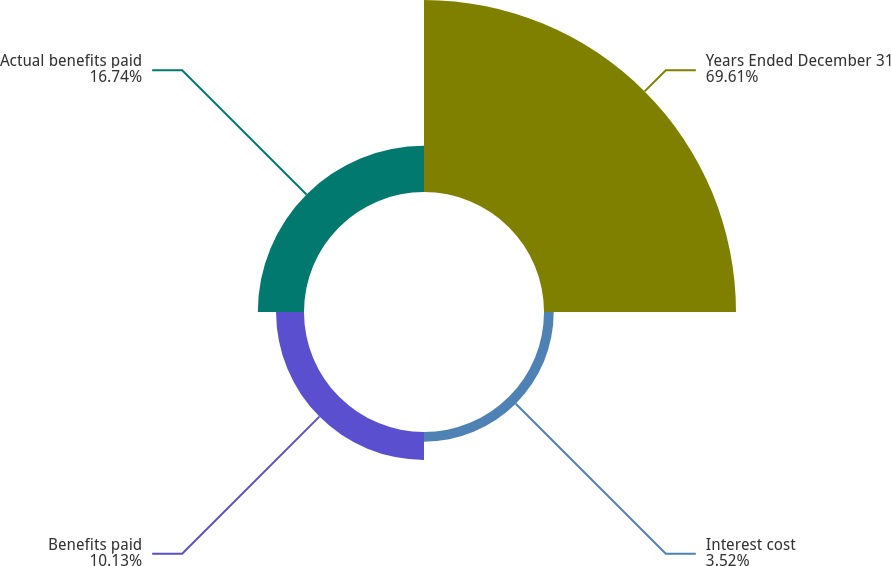Convert chart to OTSL. <chart><loc_0><loc_0><loc_500><loc_500><pie_chart><fcel>Years Ended December 31<fcel>Interest cost<fcel>Benefits paid<fcel>Actual benefits paid<nl><fcel>69.61%<fcel>3.52%<fcel>10.13%<fcel>16.74%<nl></chart> 